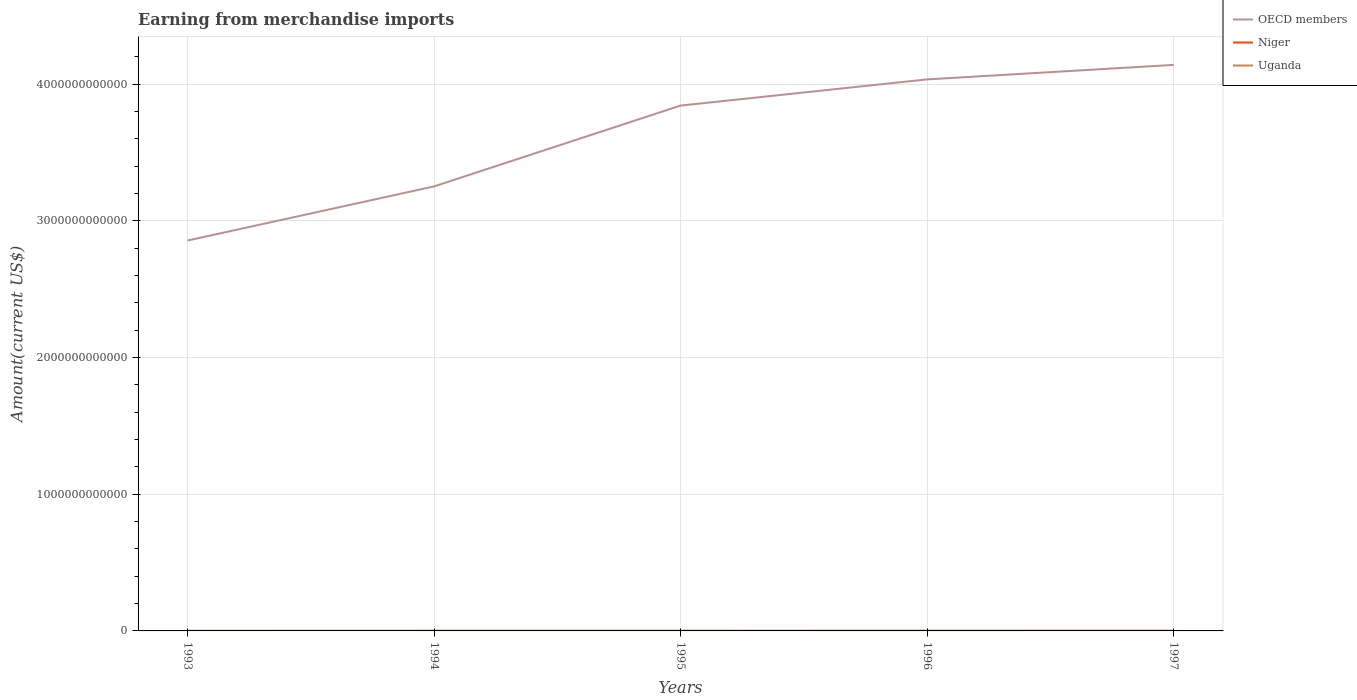How many different coloured lines are there?
Your answer should be very brief. 3. Does the line corresponding to Niger intersect with the line corresponding to Uganda?
Give a very brief answer. No. Across all years, what is the maximum amount earned from merchandise imports in OECD members?
Provide a short and direct response. 2.86e+12. What is the total amount earned from merchandise imports in OECD members in the graph?
Your response must be concise. -1.92e+11. What is the difference between the highest and the second highest amount earned from merchandise imports in Niger?
Make the answer very short. 1.20e+08. How many lines are there?
Your response must be concise. 3. How many years are there in the graph?
Your answer should be very brief. 5. What is the difference between two consecutive major ticks on the Y-axis?
Provide a succinct answer. 1.00e+12. Does the graph contain any zero values?
Make the answer very short. No. Does the graph contain grids?
Provide a succinct answer. Yes. Where does the legend appear in the graph?
Keep it short and to the point. Top right. What is the title of the graph?
Give a very brief answer. Earning from merchandise imports. What is the label or title of the X-axis?
Make the answer very short. Years. What is the label or title of the Y-axis?
Your answer should be very brief. Amount(current US$). What is the Amount(current US$) of OECD members in 1993?
Your answer should be compact. 2.86e+12. What is the Amount(current US$) of Niger in 1993?
Your answer should be compact. 3.75e+08. What is the Amount(current US$) of Uganda in 1993?
Your answer should be very brief. 5.35e+08. What is the Amount(current US$) of OECD members in 1994?
Your answer should be compact. 3.25e+12. What is the Amount(current US$) of Niger in 1994?
Offer a terse response. 3.28e+08. What is the Amount(current US$) of Uganda in 1994?
Your answer should be very brief. 8.75e+08. What is the Amount(current US$) of OECD members in 1995?
Ensure brevity in your answer.  3.84e+12. What is the Amount(current US$) of Niger in 1995?
Ensure brevity in your answer.  3.74e+08. What is the Amount(current US$) in Uganda in 1995?
Provide a short and direct response. 1.06e+09. What is the Amount(current US$) of OECD members in 1996?
Ensure brevity in your answer.  4.04e+12. What is the Amount(current US$) in Niger in 1996?
Keep it short and to the point. 4.48e+08. What is the Amount(current US$) in Uganda in 1996?
Your answer should be compact. 1.19e+09. What is the Amount(current US$) of OECD members in 1997?
Make the answer very short. 4.14e+12. What is the Amount(current US$) of Niger in 1997?
Ensure brevity in your answer.  3.74e+08. What is the Amount(current US$) of Uganda in 1997?
Offer a very short reply. 1.32e+09. Across all years, what is the maximum Amount(current US$) of OECD members?
Your answer should be very brief. 4.14e+12. Across all years, what is the maximum Amount(current US$) of Niger?
Offer a very short reply. 4.48e+08. Across all years, what is the maximum Amount(current US$) of Uganda?
Make the answer very short. 1.32e+09. Across all years, what is the minimum Amount(current US$) in OECD members?
Your response must be concise. 2.86e+12. Across all years, what is the minimum Amount(current US$) in Niger?
Provide a short and direct response. 3.28e+08. Across all years, what is the minimum Amount(current US$) of Uganda?
Your answer should be very brief. 5.35e+08. What is the total Amount(current US$) in OECD members in the graph?
Your answer should be very brief. 1.81e+13. What is the total Amount(current US$) in Niger in the graph?
Ensure brevity in your answer.  1.90e+09. What is the total Amount(current US$) in Uganda in the graph?
Give a very brief answer. 4.97e+09. What is the difference between the Amount(current US$) of OECD members in 1993 and that in 1994?
Ensure brevity in your answer.  -3.96e+11. What is the difference between the Amount(current US$) of Niger in 1993 and that in 1994?
Offer a terse response. 4.70e+07. What is the difference between the Amount(current US$) in Uganda in 1993 and that in 1994?
Give a very brief answer. -3.40e+08. What is the difference between the Amount(current US$) in OECD members in 1993 and that in 1995?
Ensure brevity in your answer.  -9.88e+11. What is the difference between the Amount(current US$) in Niger in 1993 and that in 1995?
Offer a terse response. 1.00e+06. What is the difference between the Amount(current US$) in Uganda in 1993 and that in 1995?
Make the answer very short. -5.21e+08. What is the difference between the Amount(current US$) of OECD members in 1993 and that in 1996?
Offer a very short reply. -1.18e+12. What is the difference between the Amount(current US$) of Niger in 1993 and that in 1996?
Your answer should be very brief. -7.30e+07. What is the difference between the Amount(current US$) of Uganda in 1993 and that in 1996?
Keep it short and to the point. -6.56e+08. What is the difference between the Amount(current US$) of OECD members in 1993 and that in 1997?
Keep it short and to the point. -1.29e+12. What is the difference between the Amount(current US$) of Uganda in 1993 and that in 1997?
Give a very brief answer. -7.81e+08. What is the difference between the Amount(current US$) of OECD members in 1994 and that in 1995?
Your answer should be very brief. -5.91e+11. What is the difference between the Amount(current US$) of Niger in 1994 and that in 1995?
Offer a terse response. -4.60e+07. What is the difference between the Amount(current US$) in Uganda in 1994 and that in 1995?
Your answer should be compact. -1.81e+08. What is the difference between the Amount(current US$) of OECD members in 1994 and that in 1996?
Keep it short and to the point. -7.83e+11. What is the difference between the Amount(current US$) in Niger in 1994 and that in 1996?
Your answer should be very brief. -1.20e+08. What is the difference between the Amount(current US$) in Uganda in 1994 and that in 1996?
Your response must be concise. -3.16e+08. What is the difference between the Amount(current US$) in OECD members in 1994 and that in 1997?
Offer a very short reply. -8.89e+11. What is the difference between the Amount(current US$) in Niger in 1994 and that in 1997?
Your response must be concise. -4.60e+07. What is the difference between the Amount(current US$) in Uganda in 1994 and that in 1997?
Ensure brevity in your answer.  -4.41e+08. What is the difference between the Amount(current US$) of OECD members in 1995 and that in 1996?
Your answer should be compact. -1.92e+11. What is the difference between the Amount(current US$) of Niger in 1995 and that in 1996?
Ensure brevity in your answer.  -7.40e+07. What is the difference between the Amount(current US$) of Uganda in 1995 and that in 1996?
Make the answer very short. -1.35e+08. What is the difference between the Amount(current US$) in OECD members in 1995 and that in 1997?
Give a very brief answer. -2.98e+11. What is the difference between the Amount(current US$) of Niger in 1995 and that in 1997?
Provide a succinct answer. 0. What is the difference between the Amount(current US$) of Uganda in 1995 and that in 1997?
Offer a very short reply. -2.60e+08. What is the difference between the Amount(current US$) of OECD members in 1996 and that in 1997?
Provide a succinct answer. -1.06e+11. What is the difference between the Amount(current US$) of Niger in 1996 and that in 1997?
Make the answer very short. 7.40e+07. What is the difference between the Amount(current US$) in Uganda in 1996 and that in 1997?
Your response must be concise. -1.25e+08. What is the difference between the Amount(current US$) in OECD members in 1993 and the Amount(current US$) in Niger in 1994?
Keep it short and to the point. 2.86e+12. What is the difference between the Amount(current US$) in OECD members in 1993 and the Amount(current US$) in Uganda in 1994?
Offer a terse response. 2.86e+12. What is the difference between the Amount(current US$) of Niger in 1993 and the Amount(current US$) of Uganda in 1994?
Your answer should be compact. -5.00e+08. What is the difference between the Amount(current US$) in OECD members in 1993 and the Amount(current US$) in Niger in 1995?
Your answer should be very brief. 2.86e+12. What is the difference between the Amount(current US$) in OECD members in 1993 and the Amount(current US$) in Uganda in 1995?
Provide a short and direct response. 2.86e+12. What is the difference between the Amount(current US$) in Niger in 1993 and the Amount(current US$) in Uganda in 1995?
Provide a short and direct response. -6.81e+08. What is the difference between the Amount(current US$) in OECD members in 1993 and the Amount(current US$) in Niger in 1996?
Ensure brevity in your answer.  2.86e+12. What is the difference between the Amount(current US$) in OECD members in 1993 and the Amount(current US$) in Uganda in 1996?
Make the answer very short. 2.86e+12. What is the difference between the Amount(current US$) in Niger in 1993 and the Amount(current US$) in Uganda in 1996?
Your answer should be very brief. -8.16e+08. What is the difference between the Amount(current US$) in OECD members in 1993 and the Amount(current US$) in Niger in 1997?
Give a very brief answer. 2.86e+12. What is the difference between the Amount(current US$) in OECD members in 1993 and the Amount(current US$) in Uganda in 1997?
Provide a succinct answer. 2.85e+12. What is the difference between the Amount(current US$) in Niger in 1993 and the Amount(current US$) in Uganda in 1997?
Offer a terse response. -9.41e+08. What is the difference between the Amount(current US$) in OECD members in 1994 and the Amount(current US$) in Niger in 1995?
Your answer should be very brief. 3.25e+12. What is the difference between the Amount(current US$) in OECD members in 1994 and the Amount(current US$) in Uganda in 1995?
Offer a terse response. 3.25e+12. What is the difference between the Amount(current US$) of Niger in 1994 and the Amount(current US$) of Uganda in 1995?
Offer a terse response. -7.28e+08. What is the difference between the Amount(current US$) in OECD members in 1994 and the Amount(current US$) in Niger in 1996?
Ensure brevity in your answer.  3.25e+12. What is the difference between the Amount(current US$) in OECD members in 1994 and the Amount(current US$) in Uganda in 1996?
Offer a terse response. 3.25e+12. What is the difference between the Amount(current US$) of Niger in 1994 and the Amount(current US$) of Uganda in 1996?
Make the answer very short. -8.63e+08. What is the difference between the Amount(current US$) in OECD members in 1994 and the Amount(current US$) in Niger in 1997?
Ensure brevity in your answer.  3.25e+12. What is the difference between the Amount(current US$) in OECD members in 1994 and the Amount(current US$) in Uganda in 1997?
Your answer should be very brief. 3.25e+12. What is the difference between the Amount(current US$) in Niger in 1994 and the Amount(current US$) in Uganda in 1997?
Your answer should be very brief. -9.88e+08. What is the difference between the Amount(current US$) of OECD members in 1995 and the Amount(current US$) of Niger in 1996?
Your answer should be very brief. 3.84e+12. What is the difference between the Amount(current US$) of OECD members in 1995 and the Amount(current US$) of Uganda in 1996?
Give a very brief answer. 3.84e+12. What is the difference between the Amount(current US$) in Niger in 1995 and the Amount(current US$) in Uganda in 1996?
Your response must be concise. -8.17e+08. What is the difference between the Amount(current US$) in OECD members in 1995 and the Amount(current US$) in Niger in 1997?
Ensure brevity in your answer.  3.84e+12. What is the difference between the Amount(current US$) of OECD members in 1995 and the Amount(current US$) of Uganda in 1997?
Provide a succinct answer. 3.84e+12. What is the difference between the Amount(current US$) of Niger in 1995 and the Amount(current US$) of Uganda in 1997?
Provide a succinct answer. -9.42e+08. What is the difference between the Amount(current US$) in OECD members in 1996 and the Amount(current US$) in Niger in 1997?
Ensure brevity in your answer.  4.03e+12. What is the difference between the Amount(current US$) in OECD members in 1996 and the Amount(current US$) in Uganda in 1997?
Provide a short and direct response. 4.03e+12. What is the difference between the Amount(current US$) of Niger in 1996 and the Amount(current US$) of Uganda in 1997?
Your answer should be very brief. -8.68e+08. What is the average Amount(current US$) of OECD members per year?
Provide a succinct answer. 3.63e+12. What is the average Amount(current US$) in Niger per year?
Make the answer very short. 3.80e+08. What is the average Amount(current US$) of Uganda per year?
Keep it short and to the point. 9.95e+08. In the year 1993, what is the difference between the Amount(current US$) of OECD members and Amount(current US$) of Niger?
Offer a terse response. 2.86e+12. In the year 1993, what is the difference between the Amount(current US$) in OECD members and Amount(current US$) in Uganda?
Provide a short and direct response. 2.86e+12. In the year 1993, what is the difference between the Amount(current US$) of Niger and Amount(current US$) of Uganda?
Give a very brief answer. -1.60e+08. In the year 1994, what is the difference between the Amount(current US$) of OECD members and Amount(current US$) of Niger?
Your answer should be very brief. 3.25e+12. In the year 1994, what is the difference between the Amount(current US$) of OECD members and Amount(current US$) of Uganda?
Your answer should be very brief. 3.25e+12. In the year 1994, what is the difference between the Amount(current US$) in Niger and Amount(current US$) in Uganda?
Keep it short and to the point. -5.47e+08. In the year 1995, what is the difference between the Amount(current US$) in OECD members and Amount(current US$) in Niger?
Make the answer very short. 3.84e+12. In the year 1995, what is the difference between the Amount(current US$) in OECD members and Amount(current US$) in Uganda?
Your response must be concise. 3.84e+12. In the year 1995, what is the difference between the Amount(current US$) in Niger and Amount(current US$) in Uganda?
Offer a very short reply. -6.82e+08. In the year 1996, what is the difference between the Amount(current US$) in OECD members and Amount(current US$) in Niger?
Provide a short and direct response. 4.03e+12. In the year 1996, what is the difference between the Amount(current US$) in OECD members and Amount(current US$) in Uganda?
Your answer should be compact. 4.03e+12. In the year 1996, what is the difference between the Amount(current US$) of Niger and Amount(current US$) of Uganda?
Your answer should be compact. -7.43e+08. In the year 1997, what is the difference between the Amount(current US$) in OECD members and Amount(current US$) in Niger?
Your response must be concise. 4.14e+12. In the year 1997, what is the difference between the Amount(current US$) in OECD members and Amount(current US$) in Uganda?
Offer a very short reply. 4.14e+12. In the year 1997, what is the difference between the Amount(current US$) in Niger and Amount(current US$) in Uganda?
Provide a succinct answer. -9.42e+08. What is the ratio of the Amount(current US$) in OECD members in 1993 to that in 1994?
Provide a succinct answer. 0.88. What is the ratio of the Amount(current US$) in Niger in 1993 to that in 1994?
Your answer should be very brief. 1.14. What is the ratio of the Amount(current US$) of Uganda in 1993 to that in 1994?
Offer a very short reply. 0.61. What is the ratio of the Amount(current US$) of OECD members in 1993 to that in 1995?
Ensure brevity in your answer.  0.74. What is the ratio of the Amount(current US$) in Uganda in 1993 to that in 1995?
Keep it short and to the point. 0.51. What is the ratio of the Amount(current US$) in OECD members in 1993 to that in 1996?
Ensure brevity in your answer.  0.71. What is the ratio of the Amount(current US$) in Niger in 1993 to that in 1996?
Make the answer very short. 0.84. What is the ratio of the Amount(current US$) of Uganda in 1993 to that in 1996?
Offer a very short reply. 0.45. What is the ratio of the Amount(current US$) in OECD members in 1993 to that in 1997?
Give a very brief answer. 0.69. What is the ratio of the Amount(current US$) of Niger in 1993 to that in 1997?
Provide a short and direct response. 1. What is the ratio of the Amount(current US$) in Uganda in 1993 to that in 1997?
Ensure brevity in your answer.  0.41. What is the ratio of the Amount(current US$) of OECD members in 1994 to that in 1995?
Your response must be concise. 0.85. What is the ratio of the Amount(current US$) in Niger in 1994 to that in 1995?
Your response must be concise. 0.88. What is the ratio of the Amount(current US$) in Uganda in 1994 to that in 1995?
Offer a terse response. 0.83. What is the ratio of the Amount(current US$) in OECD members in 1994 to that in 1996?
Offer a very short reply. 0.81. What is the ratio of the Amount(current US$) in Niger in 1994 to that in 1996?
Offer a very short reply. 0.73. What is the ratio of the Amount(current US$) of Uganda in 1994 to that in 1996?
Provide a short and direct response. 0.73. What is the ratio of the Amount(current US$) of OECD members in 1994 to that in 1997?
Make the answer very short. 0.79. What is the ratio of the Amount(current US$) in Niger in 1994 to that in 1997?
Your answer should be compact. 0.88. What is the ratio of the Amount(current US$) of Uganda in 1994 to that in 1997?
Your answer should be compact. 0.66. What is the ratio of the Amount(current US$) in OECD members in 1995 to that in 1996?
Keep it short and to the point. 0.95. What is the ratio of the Amount(current US$) of Niger in 1995 to that in 1996?
Your answer should be very brief. 0.83. What is the ratio of the Amount(current US$) of Uganda in 1995 to that in 1996?
Make the answer very short. 0.89. What is the ratio of the Amount(current US$) of OECD members in 1995 to that in 1997?
Keep it short and to the point. 0.93. What is the ratio of the Amount(current US$) of Niger in 1995 to that in 1997?
Provide a succinct answer. 1. What is the ratio of the Amount(current US$) of Uganda in 1995 to that in 1997?
Your answer should be very brief. 0.8. What is the ratio of the Amount(current US$) in OECD members in 1996 to that in 1997?
Offer a very short reply. 0.97. What is the ratio of the Amount(current US$) in Niger in 1996 to that in 1997?
Ensure brevity in your answer.  1.2. What is the ratio of the Amount(current US$) of Uganda in 1996 to that in 1997?
Keep it short and to the point. 0.91. What is the difference between the highest and the second highest Amount(current US$) of OECD members?
Offer a terse response. 1.06e+11. What is the difference between the highest and the second highest Amount(current US$) in Niger?
Offer a very short reply. 7.30e+07. What is the difference between the highest and the second highest Amount(current US$) in Uganda?
Offer a terse response. 1.25e+08. What is the difference between the highest and the lowest Amount(current US$) of OECD members?
Give a very brief answer. 1.29e+12. What is the difference between the highest and the lowest Amount(current US$) of Niger?
Keep it short and to the point. 1.20e+08. What is the difference between the highest and the lowest Amount(current US$) in Uganda?
Ensure brevity in your answer.  7.81e+08. 